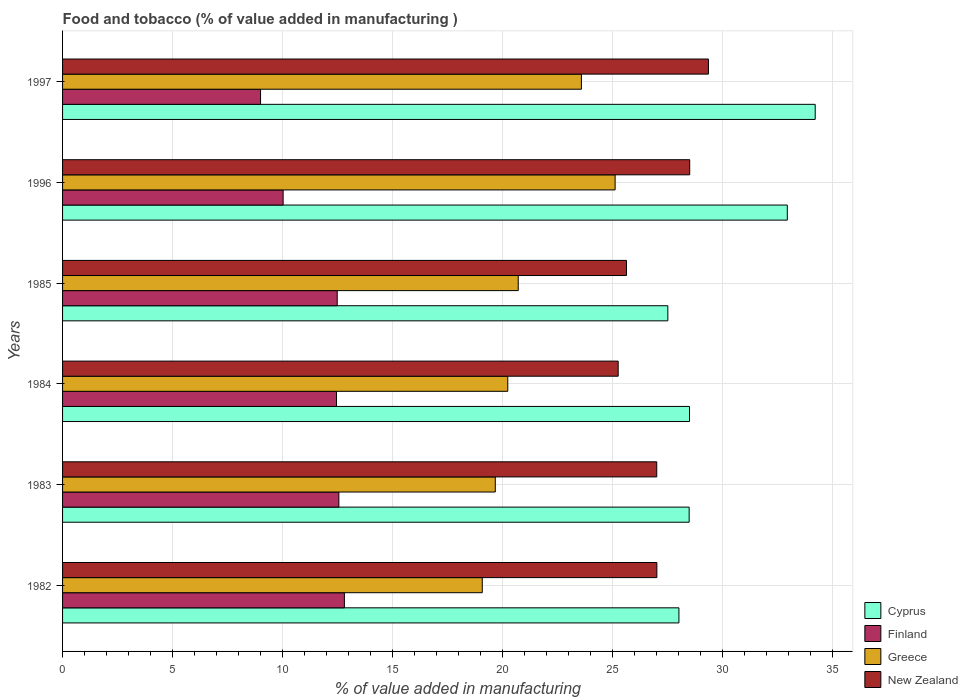Are the number of bars on each tick of the Y-axis equal?
Offer a terse response. Yes. How many bars are there on the 5th tick from the top?
Offer a terse response. 4. What is the value added in manufacturing food and tobacco in New Zealand in 1997?
Your answer should be compact. 29.37. Across all years, what is the maximum value added in manufacturing food and tobacco in Cyprus?
Your answer should be very brief. 34.23. Across all years, what is the minimum value added in manufacturing food and tobacco in Finland?
Offer a very short reply. 9. In which year was the value added in manufacturing food and tobacco in Finland maximum?
Ensure brevity in your answer.  1982. In which year was the value added in manufacturing food and tobacco in New Zealand minimum?
Your answer should be very brief. 1984. What is the total value added in manufacturing food and tobacco in Finland in the graph?
Provide a short and direct response. 69.36. What is the difference between the value added in manufacturing food and tobacco in Cyprus in 1982 and that in 1983?
Your answer should be very brief. -0.47. What is the difference between the value added in manufacturing food and tobacco in Greece in 1997 and the value added in manufacturing food and tobacco in New Zealand in 1984?
Keep it short and to the point. -1.67. What is the average value added in manufacturing food and tobacco in New Zealand per year?
Your response must be concise. 27.14. In the year 1985, what is the difference between the value added in manufacturing food and tobacco in Greece and value added in manufacturing food and tobacco in Finland?
Ensure brevity in your answer.  8.23. In how many years, is the value added in manufacturing food and tobacco in Greece greater than 7 %?
Make the answer very short. 6. What is the ratio of the value added in manufacturing food and tobacco in New Zealand in 1982 to that in 1996?
Provide a short and direct response. 0.95. Is the difference between the value added in manufacturing food and tobacco in Greece in 1984 and 1985 greater than the difference between the value added in manufacturing food and tobacco in Finland in 1984 and 1985?
Keep it short and to the point. No. What is the difference between the highest and the second highest value added in manufacturing food and tobacco in Greece?
Provide a succinct answer. 1.53. What is the difference between the highest and the lowest value added in manufacturing food and tobacco in Greece?
Offer a very short reply. 6.04. Is the sum of the value added in manufacturing food and tobacco in Cyprus in 1983 and 1985 greater than the maximum value added in manufacturing food and tobacco in Finland across all years?
Provide a short and direct response. Yes. What does the 2nd bar from the top in 1997 represents?
Provide a succinct answer. Greece. What does the 3rd bar from the bottom in 1997 represents?
Keep it short and to the point. Greece. How many bars are there?
Your response must be concise. 24. Are all the bars in the graph horizontal?
Ensure brevity in your answer.  Yes. How many years are there in the graph?
Offer a terse response. 6. What is the difference between two consecutive major ticks on the X-axis?
Ensure brevity in your answer.  5. Are the values on the major ticks of X-axis written in scientific E-notation?
Keep it short and to the point. No. Does the graph contain grids?
Your response must be concise. Yes. Where does the legend appear in the graph?
Give a very brief answer. Bottom right. How many legend labels are there?
Offer a very short reply. 4. How are the legend labels stacked?
Make the answer very short. Vertical. What is the title of the graph?
Offer a terse response. Food and tobacco (% of value added in manufacturing ). What is the label or title of the X-axis?
Offer a very short reply. % of value added in manufacturing. What is the label or title of the Y-axis?
Offer a very short reply. Years. What is the % of value added in manufacturing in Cyprus in 1982?
Offer a terse response. 28.03. What is the % of value added in manufacturing of Finland in 1982?
Ensure brevity in your answer.  12.82. What is the % of value added in manufacturing of Greece in 1982?
Keep it short and to the point. 19.09. What is the % of value added in manufacturing of New Zealand in 1982?
Your answer should be very brief. 27.03. What is the % of value added in manufacturing in Cyprus in 1983?
Provide a short and direct response. 28.49. What is the % of value added in manufacturing of Finland in 1983?
Ensure brevity in your answer.  12.56. What is the % of value added in manufacturing in Greece in 1983?
Ensure brevity in your answer.  19.68. What is the % of value added in manufacturing in New Zealand in 1983?
Keep it short and to the point. 27.02. What is the % of value added in manufacturing in Cyprus in 1984?
Offer a very short reply. 28.51. What is the % of value added in manufacturing of Finland in 1984?
Provide a succinct answer. 12.46. What is the % of value added in manufacturing in Greece in 1984?
Your response must be concise. 20.25. What is the % of value added in manufacturing of New Zealand in 1984?
Your answer should be very brief. 25.27. What is the % of value added in manufacturing of Cyprus in 1985?
Give a very brief answer. 27.52. What is the % of value added in manufacturing of Finland in 1985?
Make the answer very short. 12.49. What is the % of value added in manufacturing of Greece in 1985?
Provide a short and direct response. 20.72. What is the % of value added in manufacturing of New Zealand in 1985?
Provide a succinct answer. 25.64. What is the % of value added in manufacturing in Cyprus in 1996?
Keep it short and to the point. 32.96. What is the % of value added in manufacturing of Finland in 1996?
Keep it short and to the point. 10.03. What is the % of value added in manufacturing of Greece in 1996?
Your answer should be compact. 25.13. What is the % of value added in manufacturing in New Zealand in 1996?
Your answer should be compact. 28.52. What is the % of value added in manufacturing in Cyprus in 1997?
Offer a terse response. 34.23. What is the % of value added in manufacturing of Finland in 1997?
Offer a very short reply. 9. What is the % of value added in manufacturing of Greece in 1997?
Keep it short and to the point. 23.59. What is the % of value added in manufacturing of New Zealand in 1997?
Offer a terse response. 29.37. Across all years, what is the maximum % of value added in manufacturing in Cyprus?
Provide a short and direct response. 34.23. Across all years, what is the maximum % of value added in manufacturing in Finland?
Ensure brevity in your answer.  12.82. Across all years, what is the maximum % of value added in manufacturing in Greece?
Provide a short and direct response. 25.13. Across all years, what is the maximum % of value added in manufacturing in New Zealand?
Your response must be concise. 29.37. Across all years, what is the minimum % of value added in manufacturing in Cyprus?
Offer a terse response. 27.52. Across all years, what is the minimum % of value added in manufacturing in Finland?
Offer a terse response. 9. Across all years, what is the minimum % of value added in manufacturing in Greece?
Provide a short and direct response. 19.09. Across all years, what is the minimum % of value added in manufacturing in New Zealand?
Offer a very short reply. 25.27. What is the total % of value added in manufacturing in Cyprus in the graph?
Offer a very short reply. 179.74. What is the total % of value added in manufacturing of Finland in the graph?
Provide a short and direct response. 69.36. What is the total % of value added in manufacturing in Greece in the graph?
Give a very brief answer. 128.45. What is the total % of value added in manufacturing in New Zealand in the graph?
Your answer should be compact. 162.85. What is the difference between the % of value added in manufacturing of Cyprus in 1982 and that in 1983?
Your answer should be compact. -0.47. What is the difference between the % of value added in manufacturing in Finland in 1982 and that in 1983?
Make the answer very short. 0.25. What is the difference between the % of value added in manufacturing in Greece in 1982 and that in 1983?
Your answer should be compact. -0.59. What is the difference between the % of value added in manufacturing in New Zealand in 1982 and that in 1983?
Offer a terse response. 0.01. What is the difference between the % of value added in manufacturing in Cyprus in 1982 and that in 1984?
Provide a short and direct response. -0.48. What is the difference between the % of value added in manufacturing of Finland in 1982 and that in 1984?
Ensure brevity in your answer.  0.36. What is the difference between the % of value added in manufacturing in Greece in 1982 and that in 1984?
Your answer should be very brief. -1.16. What is the difference between the % of value added in manufacturing of New Zealand in 1982 and that in 1984?
Make the answer very short. 1.76. What is the difference between the % of value added in manufacturing in Cyprus in 1982 and that in 1985?
Provide a succinct answer. 0.5. What is the difference between the % of value added in manufacturing of Finland in 1982 and that in 1985?
Keep it short and to the point. 0.33. What is the difference between the % of value added in manufacturing in Greece in 1982 and that in 1985?
Give a very brief answer. -1.64. What is the difference between the % of value added in manufacturing of New Zealand in 1982 and that in 1985?
Provide a succinct answer. 1.38. What is the difference between the % of value added in manufacturing of Cyprus in 1982 and that in 1996?
Ensure brevity in your answer.  -4.93. What is the difference between the % of value added in manufacturing in Finland in 1982 and that in 1996?
Provide a succinct answer. 2.79. What is the difference between the % of value added in manufacturing in Greece in 1982 and that in 1996?
Your answer should be compact. -6.04. What is the difference between the % of value added in manufacturing of New Zealand in 1982 and that in 1996?
Your answer should be compact. -1.49. What is the difference between the % of value added in manufacturing in Cyprus in 1982 and that in 1997?
Offer a very short reply. -6.2. What is the difference between the % of value added in manufacturing of Finland in 1982 and that in 1997?
Make the answer very short. 3.81. What is the difference between the % of value added in manufacturing in Greece in 1982 and that in 1997?
Keep it short and to the point. -4.51. What is the difference between the % of value added in manufacturing in New Zealand in 1982 and that in 1997?
Offer a terse response. -2.34. What is the difference between the % of value added in manufacturing in Cyprus in 1983 and that in 1984?
Keep it short and to the point. -0.02. What is the difference between the % of value added in manufacturing of Finland in 1983 and that in 1984?
Offer a terse response. 0.11. What is the difference between the % of value added in manufacturing in Greece in 1983 and that in 1984?
Your answer should be compact. -0.57. What is the difference between the % of value added in manufacturing of New Zealand in 1983 and that in 1984?
Give a very brief answer. 1.75. What is the difference between the % of value added in manufacturing of Cyprus in 1983 and that in 1985?
Give a very brief answer. 0.97. What is the difference between the % of value added in manufacturing of Finland in 1983 and that in 1985?
Make the answer very short. 0.07. What is the difference between the % of value added in manufacturing in Greece in 1983 and that in 1985?
Your answer should be compact. -1.04. What is the difference between the % of value added in manufacturing in New Zealand in 1983 and that in 1985?
Your answer should be very brief. 1.38. What is the difference between the % of value added in manufacturing in Cyprus in 1983 and that in 1996?
Your response must be concise. -4.46. What is the difference between the % of value added in manufacturing in Finland in 1983 and that in 1996?
Your answer should be very brief. 2.53. What is the difference between the % of value added in manufacturing in Greece in 1983 and that in 1996?
Ensure brevity in your answer.  -5.45. What is the difference between the % of value added in manufacturing in New Zealand in 1983 and that in 1996?
Make the answer very short. -1.5. What is the difference between the % of value added in manufacturing of Cyprus in 1983 and that in 1997?
Provide a succinct answer. -5.73. What is the difference between the % of value added in manufacturing in Finland in 1983 and that in 1997?
Your response must be concise. 3.56. What is the difference between the % of value added in manufacturing in Greece in 1983 and that in 1997?
Make the answer very short. -3.92. What is the difference between the % of value added in manufacturing of New Zealand in 1983 and that in 1997?
Ensure brevity in your answer.  -2.35. What is the difference between the % of value added in manufacturing of Cyprus in 1984 and that in 1985?
Give a very brief answer. 0.99. What is the difference between the % of value added in manufacturing of Finland in 1984 and that in 1985?
Your response must be concise. -0.03. What is the difference between the % of value added in manufacturing in Greece in 1984 and that in 1985?
Ensure brevity in your answer.  -0.48. What is the difference between the % of value added in manufacturing of New Zealand in 1984 and that in 1985?
Give a very brief answer. -0.38. What is the difference between the % of value added in manufacturing of Cyprus in 1984 and that in 1996?
Give a very brief answer. -4.45. What is the difference between the % of value added in manufacturing in Finland in 1984 and that in 1996?
Make the answer very short. 2.43. What is the difference between the % of value added in manufacturing of Greece in 1984 and that in 1996?
Provide a succinct answer. -4.88. What is the difference between the % of value added in manufacturing of New Zealand in 1984 and that in 1996?
Make the answer very short. -3.25. What is the difference between the % of value added in manufacturing of Cyprus in 1984 and that in 1997?
Give a very brief answer. -5.72. What is the difference between the % of value added in manufacturing in Finland in 1984 and that in 1997?
Your answer should be very brief. 3.45. What is the difference between the % of value added in manufacturing of Greece in 1984 and that in 1997?
Your answer should be very brief. -3.35. What is the difference between the % of value added in manufacturing of New Zealand in 1984 and that in 1997?
Your answer should be very brief. -4.1. What is the difference between the % of value added in manufacturing of Cyprus in 1985 and that in 1996?
Keep it short and to the point. -5.43. What is the difference between the % of value added in manufacturing of Finland in 1985 and that in 1996?
Provide a short and direct response. 2.46. What is the difference between the % of value added in manufacturing in Greece in 1985 and that in 1996?
Give a very brief answer. -4.41. What is the difference between the % of value added in manufacturing in New Zealand in 1985 and that in 1996?
Your answer should be compact. -2.88. What is the difference between the % of value added in manufacturing in Cyprus in 1985 and that in 1997?
Your answer should be compact. -6.7. What is the difference between the % of value added in manufacturing of Finland in 1985 and that in 1997?
Give a very brief answer. 3.49. What is the difference between the % of value added in manufacturing of Greece in 1985 and that in 1997?
Ensure brevity in your answer.  -2.87. What is the difference between the % of value added in manufacturing of New Zealand in 1985 and that in 1997?
Ensure brevity in your answer.  -3.73. What is the difference between the % of value added in manufacturing of Cyprus in 1996 and that in 1997?
Offer a very short reply. -1.27. What is the difference between the % of value added in manufacturing of Finland in 1996 and that in 1997?
Ensure brevity in your answer.  1.03. What is the difference between the % of value added in manufacturing in Greece in 1996 and that in 1997?
Keep it short and to the point. 1.53. What is the difference between the % of value added in manufacturing in New Zealand in 1996 and that in 1997?
Ensure brevity in your answer.  -0.85. What is the difference between the % of value added in manufacturing of Cyprus in 1982 and the % of value added in manufacturing of Finland in 1983?
Your response must be concise. 15.46. What is the difference between the % of value added in manufacturing in Cyprus in 1982 and the % of value added in manufacturing in Greece in 1983?
Give a very brief answer. 8.35. What is the difference between the % of value added in manufacturing in Finland in 1982 and the % of value added in manufacturing in Greece in 1983?
Keep it short and to the point. -6.86. What is the difference between the % of value added in manufacturing of Finland in 1982 and the % of value added in manufacturing of New Zealand in 1983?
Provide a short and direct response. -14.2. What is the difference between the % of value added in manufacturing of Greece in 1982 and the % of value added in manufacturing of New Zealand in 1983?
Provide a succinct answer. -7.94. What is the difference between the % of value added in manufacturing in Cyprus in 1982 and the % of value added in manufacturing in Finland in 1984?
Make the answer very short. 15.57. What is the difference between the % of value added in manufacturing of Cyprus in 1982 and the % of value added in manufacturing of Greece in 1984?
Provide a short and direct response. 7.78. What is the difference between the % of value added in manufacturing of Cyprus in 1982 and the % of value added in manufacturing of New Zealand in 1984?
Offer a very short reply. 2.76. What is the difference between the % of value added in manufacturing of Finland in 1982 and the % of value added in manufacturing of Greece in 1984?
Provide a short and direct response. -7.43. What is the difference between the % of value added in manufacturing of Finland in 1982 and the % of value added in manufacturing of New Zealand in 1984?
Offer a terse response. -12.45. What is the difference between the % of value added in manufacturing of Greece in 1982 and the % of value added in manufacturing of New Zealand in 1984?
Offer a very short reply. -6.18. What is the difference between the % of value added in manufacturing of Cyprus in 1982 and the % of value added in manufacturing of Finland in 1985?
Your response must be concise. 15.54. What is the difference between the % of value added in manufacturing of Cyprus in 1982 and the % of value added in manufacturing of Greece in 1985?
Ensure brevity in your answer.  7.31. What is the difference between the % of value added in manufacturing in Cyprus in 1982 and the % of value added in manufacturing in New Zealand in 1985?
Give a very brief answer. 2.38. What is the difference between the % of value added in manufacturing in Finland in 1982 and the % of value added in manufacturing in Greece in 1985?
Your response must be concise. -7.91. What is the difference between the % of value added in manufacturing of Finland in 1982 and the % of value added in manufacturing of New Zealand in 1985?
Your response must be concise. -12.83. What is the difference between the % of value added in manufacturing in Greece in 1982 and the % of value added in manufacturing in New Zealand in 1985?
Provide a short and direct response. -6.56. What is the difference between the % of value added in manufacturing of Cyprus in 1982 and the % of value added in manufacturing of Finland in 1996?
Keep it short and to the point. 18. What is the difference between the % of value added in manufacturing in Cyprus in 1982 and the % of value added in manufacturing in Greece in 1996?
Offer a very short reply. 2.9. What is the difference between the % of value added in manufacturing of Cyprus in 1982 and the % of value added in manufacturing of New Zealand in 1996?
Your response must be concise. -0.49. What is the difference between the % of value added in manufacturing of Finland in 1982 and the % of value added in manufacturing of Greece in 1996?
Your answer should be compact. -12.31. What is the difference between the % of value added in manufacturing of Finland in 1982 and the % of value added in manufacturing of New Zealand in 1996?
Your response must be concise. -15.7. What is the difference between the % of value added in manufacturing of Greece in 1982 and the % of value added in manufacturing of New Zealand in 1996?
Your answer should be very brief. -9.43. What is the difference between the % of value added in manufacturing of Cyprus in 1982 and the % of value added in manufacturing of Finland in 1997?
Your answer should be compact. 19.03. What is the difference between the % of value added in manufacturing in Cyprus in 1982 and the % of value added in manufacturing in Greece in 1997?
Your answer should be very brief. 4.43. What is the difference between the % of value added in manufacturing in Cyprus in 1982 and the % of value added in manufacturing in New Zealand in 1997?
Make the answer very short. -1.34. What is the difference between the % of value added in manufacturing of Finland in 1982 and the % of value added in manufacturing of Greece in 1997?
Offer a terse response. -10.78. What is the difference between the % of value added in manufacturing of Finland in 1982 and the % of value added in manufacturing of New Zealand in 1997?
Ensure brevity in your answer.  -16.55. What is the difference between the % of value added in manufacturing in Greece in 1982 and the % of value added in manufacturing in New Zealand in 1997?
Make the answer very short. -10.29. What is the difference between the % of value added in manufacturing in Cyprus in 1983 and the % of value added in manufacturing in Finland in 1984?
Keep it short and to the point. 16.04. What is the difference between the % of value added in manufacturing in Cyprus in 1983 and the % of value added in manufacturing in Greece in 1984?
Provide a short and direct response. 8.25. What is the difference between the % of value added in manufacturing in Cyprus in 1983 and the % of value added in manufacturing in New Zealand in 1984?
Provide a succinct answer. 3.23. What is the difference between the % of value added in manufacturing of Finland in 1983 and the % of value added in manufacturing of Greece in 1984?
Give a very brief answer. -7.68. What is the difference between the % of value added in manufacturing in Finland in 1983 and the % of value added in manufacturing in New Zealand in 1984?
Your response must be concise. -12.7. What is the difference between the % of value added in manufacturing of Greece in 1983 and the % of value added in manufacturing of New Zealand in 1984?
Provide a succinct answer. -5.59. What is the difference between the % of value added in manufacturing in Cyprus in 1983 and the % of value added in manufacturing in Finland in 1985?
Offer a very short reply. 16. What is the difference between the % of value added in manufacturing of Cyprus in 1983 and the % of value added in manufacturing of Greece in 1985?
Provide a succinct answer. 7.77. What is the difference between the % of value added in manufacturing in Cyprus in 1983 and the % of value added in manufacturing in New Zealand in 1985?
Offer a very short reply. 2.85. What is the difference between the % of value added in manufacturing in Finland in 1983 and the % of value added in manufacturing in Greece in 1985?
Make the answer very short. -8.16. What is the difference between the % of value added in manufacturing of Finland in 1983 and the % of value added in manufacturing of New Zealand in 1985?
Ensure brevity in your answer.  -13.08. What is the difference between the % of value added in manufacturing in Greece in 1983 and the % of value added in manufacturing in New Zealand in 1985?
Your answer should be very brief. -5.97. What is the difference between the % of value added in manufacturing in Cyprus in 1983 and the % of value added in manufacturing in Finland in 1996?
Give a very brief answer. 18.46. What is the difference between the % of value added in manufacturing in Cyprus in 1983 and the % of value added in manufacturing in Greece in 1996?
Your response must be concise. 3.37. What is the difference between the % of value added in manufacturing of Cyprus in 1983 and the % of value added in manufacturing of New Zealand in 1996?
Provide a succinct answer. -0.02. What is the difference between the % of value added in manufacturing in Finland in 1983 and the % of value added in manufacturing in Greece in 1996?
Offer a terse response. -12.56. What is the difference between the % of value added in manufacturing in Finland in 1983 and the % of value added in manufacturing in New Zealand in 1996?
Provide a succinct answer. -15.95. What is the difference between the % of value added in manufacturing in Greece in 1983 and the % of value added in manufacturing in New Zealand in 1996?
Your answer should be very brief. -8.84. What is the difference between the % of value added in manufacturing in Cyprus in 1983 and the % of value added in manufacturing in Finland in 1997?
Your answer should be compact. 19.49. What is the difference between the % of value added in manufacturing of Cyprus in 1983 and the % of value added in manufacturing of Greece in 1997?
Offer a very short reply. 4.9. What is the difference between the % of value added in manufacturing of Cyprus in 1983 and the % of value added in manufacturing of New Zealand in 1997?
Your answer should be compact. -0.88. What is the difference between the % of value added in manufacturing in Finland in 1983 and the % of value added in manufacturing in Greece in 1997?
Ensure brevity in your answer.  -11.03. What is the difference between the % of value added in manufacturing of Finland in 1983 and the % of value added in manufacturing of New Zealand in 1997?
Your answer should be very brief. -16.81. What is the difference between the % of value added in manufacturing of Greece in 1983 and the % of value added in manufacturing of New Zealand in 1997?
Your answer should be compact. -9.69. What is the difference between the % of value added in manufacturing in Cyprus in 1984 and the % of value added in manufacturing in Finland in 1985?
Keep it short and to the point. 16.02. What is the difference between the % of value added in manufacturing in Cyprus in 1984 and the % of value added in manufacturing in Greece in 1985?
Offer a very short reply. 7.79. What is the difference between the % of value added in manufacturing in Cyprus in 1984 and the % of value added in manufacturing in New Zealand in 1985?
Your response must be concise. 2.87. What is the difference between the % of value added in manufacturing in Finland in 1984 and the % of value added in manufacturing in Greece in 1985?
Your answer should be compact. -8.26. What is the difference between the % of value added in manufacturing in Finland in 1984 and the % of value added in manufacturing in New Zealand in 1985?
Offer a terse response. -13.19. What is the difference between the % of value added in manufacturing of Greece in 1984 and the % of value added in manufacturing of New Zealand in 1985?
Your answer should be very brief. -5.4. What is the difference between the % of value added in manufacturing of Cyprus in 1984 and the % of value added in manufacturing of Finland in 1996?
Give a very brief answer. 18.48. What is the difference between the % of value added in manufacturing of Cyprus in 1984 and the % of value added in manufacturing of Greece in 1996?
Ensure brevity in your answer.  3.38. What is the difference between the % of value added in manufacturing in Cyprus in 1984 and the % of value added in manufacturing in New Zealand in 1996?
Provide a short and direct response. -0.01. What is the difference between the % of value added in manufacturing in Finland in 1984 and the % of value added in manufacturing in Greece in 1996?
Offer a very short reply. -12.67. What is the difference between the % of value added in manufacturing in Finland in 1984 and the % of value added in manufacturing in New Zealand in 1996?
Make the answer very short. -16.06. What is the difference between the % of value added in manufacturing of Greece in 1984 and the % of value added in manufacturing of New Zealand in 1996?
Provide a short and direct response. -8.27. What is the difference between the % of value added in manufacturing of Cyprus in 1984 and the % of value added in manufacturing of Finland in 1997?
Make the answer very short. 19.51. What is the difference between the % of value added in manufacturing in Cyprus in 1984 and the % of value added in manufacturing in Greece in 1997?
Keep it short and to the point. 4.92. What is the difference between the % of value added in manufacturing in Cyprus in 1984 and the % of value added in manufacturing in New Zealand in 1997?
Keep it short and to the point. -0.86. What is the difference between the % of value added in manufacturing in Finland in 1984 and the % of value added in manufacturing in Greece in 1997?
Offer a very short reply. -11.14. What is the difference between the % of value added in manufacturing in Finland in 1984 and the % of value added in manufacturing in New Zealand in 1997?
Give a very brief answer. -16.91. What is the difference between the % of value added in manufacturing of Greece in 1984 and the % of value added in manufacturing of New Zealand in 1997?
Offer a terse response. -9.13. What is the difference between the % of value added in manufacturing of Cyprus in 1985 and the % of value added in manufacturing of Finland in 1996?
Your answer should be compact. 17.5. What is the difference between the % of value added in manufacturing in Cyprus in 1985 and the % of value added in manufacturing in Greece in 1996?
Provide a succinct answer. 2.4. What is the difference between the % of value added in manufacturing in Cyprus in 1985 and the % of value added in manufacturing in New Zealand in 1996?
Offer a terse response. -0.99. What is the difference between the % of value added in manufacturing in Finland in 1985 and the % of value added in manufacturing in Greece in 1996?
Offer a terse response. -12.64. What is the difference between the % of value added in manufacturing of Finland in 1985 and the % of value added in manufacturing of New Zealand in 1996?
Provide a succinct answer. -16.03. What is the difference between the % of value added in manufacturing of Greece in 1985 and the % of value added in manufacturing of New Zealand in 1996?
Give a very brief answer. -7.8. What is the difference between the % of value added in manufacturing of Cyprus in 1985 and the % of value added in manufacturing of Finland in 1997?
Your response must be concise. 18.52. What is the difference between the % of value added in manufacturing of Cyprus in 1985 and the % of value added in manufacturing of Greece in 1997?
Provide a succinct answer. 3.93. What is the difference between the % of value added in manufacturing of Cyprus in 1985 and the % of value added in manufacturing of New Zealand in 1997?
Provide a succinct answer. -1.85. What is the difference between the % of value added in manufacturing in Finland in 1985 and the % of value added in manufacturing in Greece in 1997?
Offer a very short reply. -11.11. What is the difference between the % of value added in manufacturing in Finland in 1985 and the % of value added in manufacturing in New Zealand in 1997?
Make the answer very short. -16.88. What is the difference between the % of value added in manufacturing of Greece in 1985 and the % of value added in manufacturing of New Zealand in 1997?
Provide a short and direct response. -8.65. What is the difference between the % of value added in manufacturing in Cyprus in 1996 and the % of value added in manufacturing in Finland in 1997?
Your answer should be compact. 23.95. What is the difference between the % of value added in manufacturing in Cyprus in 1996 and the % of value added in manufacturing in Greece in 1997?
Give a very brief answer. 9.36. What is the difference between the % of value added in manufacturing of Cyprus in 1996 and the % of value added in manufacturing of New Zealand in 1997?
Give a very brief answer. 3.59. What is the difference between the % of value added in manufacturing of Finland in 1996 and the % of value added in manufacturing of Greece in 1997?
Provide a succinct answer. -13.57. What is the difference between the % of value added in manufacturing in Finland in 1996 and the % of value added in manufacturing in New Zealand in 1997?
Keep it short and to the point. -19.34. What is the difference between the % of value added in manufacturing of Greece in 1996 and the % of value added in manufacturing of New Zealand in 1997?
Your response must be concise. -4.24. What is the average % of value added in manufacturing in Cyprus per year?
Give a very brief answer. 29.96. What is the average % of value added in manufacturing of Finland per year?
Provide a short and direct response. 11.56. What is the average % of value added in manufacturing of Greece per year?
Your answer should be very brief. 21.41. What is the average % of value added in manufacturing in New Zealand per year?
Your answer should be compact. 27.14. In the year 1982, what is the difference between the % of value added in manufacturing of Cyprus and % of value added in manufacturing of Finland?
Offer a terse response. 15.21. In the year 1982, what is the difference between the % of value added in manufacturing of Cyprus and % of value added in manufacturing of Greece?
Keep it short and to the point. 8.94. In the year 1982, what is the difference between the % of value added in manufacturing in Cyprus and % of value added in manufacturing in New Zealand?
Make the answer very short. 1. In the year 1982, what is the difference between the % of value added in manufacturing of Finland and % of value added in manufacturing of Greece?
Your answer should be very brief. -6.27. In the year 1982, what is the difference between the % of value added in manufacturing of Finland and % of value added in manufacturing of New Zealand?
Your response must be concise. -14.21. In the year 1982, what is the difference between the % of value added in manufacturing in Greece and % of value added in manufacturing in New Zealand?
Provide a succinct answer. -7.94. In the year 1983, what is the difference between the % of value added in manufacturing of Cyprus and % of value added in manufacturing of Finland?
Your response must be concise. 15.93. In the year 1983, what is the difference between the % of value added in manufacturing of Cyprus and % of value added in manufacturing of Greece?
Keep it short and to the point. 8.82. In the year 1983, what is the difference between the % of value added in manufacturing in Cyprus and % of value added in manufacturing in New Zealand?
Offer a terse response. 1.47. In the year 1983, what is the difference between the % of value added in manufacturing of Finland and % of value added in manufacturing of Greece?
Your answer should be compact. -7.11. In the year 1983, what is the difference between the % of value added in manufacturing in Finland and % of value added in manufacturing in New Zealand?
Provide a succinct answer. -14.46. In the year 1983, what is the difference between the % of value added in manufacturing in Greece and % of value added in manufacturing in New Zealand?
Keep it short and to the point. -7.34. In the year 1984, what is the difference between the % of value added in manufacturing of Cyprus and % of value added in manufacturing of Finland?
Ensure brevity in your answer.  16.05. In the year 1984, what is the difference between the % of value added in manufacturing of Cyprus and % of value added in manufacturing of Greece?
Offer a very short reply. 8.26. In the year 1984, what is the difference between the % of value added in manufacturing of Cyprus and % of value added in manufacturing of New Zealand?
Your response must be concise. 3.24. In the year 1984, what is the difference between the % of value added in manufacturing in Finland and % of value added in manufacturing in Greece?
Your answer should be very brief. -7.79. In the year 1984, what is the difference between the % of value added in manufacturing of Finland and % of value added in manufacturing of New Zealand?
Make the answer very short. -12.81. In the year 1984, what is the difference between the % of value added in manufacturing of Greece and % of value added in manufacturing of New Zealand?
Offer a very short reply. -5.02. In the year 1985, what is the difference between the % of value added in manufacturing in Cyprus and % of value added in manufacturing in Finland?
Keep it short and to the point. 15.04. In the year 1985, what is the difference between the % of value added in manufacturing of Cyprus and % of value added in manufacturing of Greece?
Make the answer very short. 6.8. In the year 1985, what is the difference between the % of value added in manufacturing in Cyprus and % of value added in manufacturing in New Zealand?
Your answer should be very brief. 1.88. In the year 1985, what is the difference between the % of value added in manufacturing in Finland and % of value added in manufacturing in Greece?
Keep it short and to the point. -8.23. In the year 1985, what is the difference between the % of value added in manufacturing in Finland and % of value added in manufacturing in New Zealand?
Keep it short and to the point. -13.15. In the year 1985, what is the difference between the % of value added in manufacturing in Greece and % of value added in manufacturing in New Zealand?
Provide a succinct answer. -4.92. In the year 1996, what is the difference between the % of value added in manufacturing of Cyprus and % of value added in manufacturing of Finland?
Provide a short and direct response. 22.93. In the year 1996, what is the difference between the % of value added in manufacturing of Cyprus and % of value added in manufacturing of Greece?
Your answer should be very brief. 7.83. In the year 1996, what is the difference between the % of value added in manufacturing of Cyprus and % of value added in manufacturing of New Zealand?
Your response must be concise. 4.44. In the year 1996, what is the difference between the % of value added in manufacturing in Finland and % of value added in manufacturing in Greece?
Your response must be concise. -15.1. In the year 1996, what is the difference between the % of value added in manufacturing in Finland and % of value added in manufacturing in New Zealand?
Ensure brevity in your answer.  -18.49. In the year 1996, what is the difference between the % of value added in manufacturing of Greece and % of value added in manufacturing of New Zealand?
Your answer should be very brief. -3.39. In the year 1997, what is the difference between the % of value added in manufacturing in Cyprus and % of value added in manufacturing in Finland?
Your response must be concise. 25.22. In the year 1997, what is the difference between the % of value added in manufacturing in Cyprus and % of value added in manufacturing in Greece?
Provide a short and direct response. 10.63. In the year 1997, what is the difference between the % of value added in manufacturing of Cyprus and % of value added in manufacturing of New Zealand?
Make the answer very short. 4.86. In the year 1997, what is the difference between the % of value added in manufacturing in Finland and % of value added in manufacturing in Greece?
Your response must be concise. -14.59. In the year 1997, what is the difference between the % of value added in manufacturing of Finland and % of value added in manufacturing of New Zealand?
Offer a very short reply. -20.37. In the year 1997, what is the difference between the % of value added in manufacturing in Greece and % of value added in manufacturing in New Zealand?
Your response must be concise. -5.78. What is the ratio of the % of value added in manufacturing in Cyprus in 1982 to that in 1983?
Your response must be concise. 0.98. What is the ratio of the % of value added in manufacturing of Greece in 1982 to that in 1983?
Keep it short and to the point. 0.97. What is the ratio of the % of value added in manufacturing of New Zealand in 1982 to that in 1983?
Your response must be concise. 1. What is the ratio of the % of value added in manufacturing in Cyprus in 1982 to that in 1984?
Your answer should be very brief. 0.98. What is the ratio of the % of value added in manufacturing of Finland in 1982 to that in 1984?
Keep it short and to the point. 1.03. What is the ratio of the % of value added in manufacturing of Greece in 1982 to that in 1984?
Your response must be concise. 0.94. What is the ratio of the % of value added in manufacturing of New Zealand in 1982 to that in 1984?
Ensure brevity in your answer.  1.07. What is the ratio of the % of value added in manufacturing in Cyprus in 1982 to that in 1985?
Keep it short and to the point. 1.02. What is the ratio of the % of value added in manufacturing of Finland in 1982 to that in 1985?
Give a very brief answer. 1.03. What is the ratio of the % of value added in manufacturing of Greece in 1982 to that in 1985?
Provide a succinct answer. 0.92. What is the ratio of the % of value added in manufacturing of New Zealand in 1982 to that in 1985?
Offer a very short reply. 1.05. What is the ratio of the % of value added in manufacturing of Cyprus in 1982 to that in 1996?
Your answer should be very brief. 0.85. What is the ratio of the % of value added in manufacturing in Finland in 1982 to that in 1996?
Your response must be concise. 1.28. What is the ratio of the % of value added in manufacturing in Greece in 1982 to that in 1996?
Offer a terse response. 0.76. What is the ratio of the % of value added in manufacturing of New Zealand in 1982 to that in 1996?
Your answer should be compact. 0.95. What is the ratio of the % of value added in manufacturing of Cyprus in 1982 to that in 1997?
Provide a succinct answer. 0.82. What is the ratio of the % of value added in manufacturing in Finland in 1982 to that in 1997?
Provide a succinct answer. 1.42. What is the ratio of the % of value added in manufacturing of Greece in 1982 to that in 1997?
Your answer should be compact. 0.81. What is the ratio of the % of value added in manufacturing in New Zealand in 1982 to that in 1997?
Ensure brevity in your answer.  0.92. What is the ratio of the % of value added in manufacturing of Finland in 1983 to that in 1984?
Make the answer very short. 1.01. What is the ratio of the % of value added in manufacturing in New Zealand in 1983 to that in 1984?
Provide a succinct answer. 1.07. What is the ratio of the % of value added in manufacturing in Cyprus in 1983 to that in 1985?
Provide a short and direct response. 1.04. What is the ratio of the % of value added in manufacturing in Greece in 1983 to that in 1985?
Provide a short and direct response. 0.95. What is the ratio of the % of value added in manufacturing in New Zealand in 1983 to that in 1985?
Provide a short and direct response. 1.05. What is the ratio of the % of value added in manufacturing of Cyprus in 1983 to that in 1996?
Your answer should be compact. 0.86. What is the ratio of the % of value added in manufacturing in Finland in 1983 to that in 1996?
Offer a very short reply. 1.25. What is the ratio of the % of value added in manufacturing in Greece in 1983 to that in 1996?
Your answer should be compact. 0.78. What is the ratio of the % of value added in manufacturing of New Zealand in 1983 to that in 1996?
Make the answer very short. 0.95. What is the ratio of the % of value added in manufacturing in Cyprus in 1983 to that in 1997?
Your answer should be very brief. 0.83. What is the ratio of the % of value added in manufacturing of Finland in 1983 to that in 1997?
Your answer should be very brief. 1.4. What is the ratio of the % of value added in manufacturing of Greece in 1983 to that in 1997?
Your answer should be compact. 0.83. What is the ratio of the % of value added in manufacturing in Cyprus in 1984 to that in 1985?
Your response must be concise. 1.04. What is the ratio of the % of value added in manufacturing of New Zealand in 1984 to that in 1985?
Give a very brief answer. 0.99. What is the ratio of the % of value added in manufacturing of Cyprus in 1984 to that in 1996?
Keep it short and to the point. 0.87. What is the ratio of the % of value added in manufacturing in Finland in 1984 to that in 1996?
Make the answer very short. 1.24. What is the ratio of the % of value added in manufacturing in Greece in 1984 to that in 1996?
Ensure brevity in your answer.  0.81. What is the ratio of the % of value added in manufacturing of New Zealand in 1984 to that in 1996?
Your answer should be compact. 0.89. What is the ratio of the % of value added in manufacturing of Cyprus in 1984 to that in 1997?
Give a very brief answer. 0.83. What is the ratio of the % of value added in manufacturing of Finland in 1984 to that in 1997?
Ensure brevity in your answer.  1.38. What is the ratio of the % of value added in manufacturing in Greece in 1984 to that in 1997?
Offer a very short reply. 0.86. What is the ratio of the % of value added in manufacturing of New Zealand in 1984 to that in 1997?
Provide a short and direct response. 0.86. What is the ratio of the % of value added in manufacturing in Cyprus in 1985 to that in 1996?
Offer a terse response. 0.84. What is the ratio of the % of value added in manufacturing in Finland in 1985 to that in 1996?
Make the answer very short. 1.25. What is the ratio of the % of value added in manufacturing in Greece in 1985 to that in 1996?
Your response must be concise. 0.82. What is the ratio of the % of value added in manufacturing in New Zealand in 1985 to that in 1996?
Give a very brief answer. 0.9. What is the ratio of the % of value added in manufacturing of Cyprus in 1985 to that in 1997?
Provide a short and direct response. 0.8. What is the ratio of the % of value added in manufacturing in Finland in 1985 to that in 1997?
Your answer should be very brief. 1.39. What is the ratio of the % of value added in manufacturing in Greece in 1985 to that in 1997?
Your response must be concise. 0.88. What is the ratio of the % of value added in manufacturing in New Zealand in 1985 to that in 1997?
Your answer should be compact. 0.87. What is the ratio of the % of value added in manufacturing in Cyprus in 1996 to that in 1997?
Ensure brevity in your answer.  0.96. What is the ratio of the % of value added in manufacturing of Finland in 1996 to that in 1997?
Your answer should be compact. 1.11. What is the ratio of the % of value added in manufacturing of Greece in 1996 to that in 1997?
Provide a short and direct response. 1.06. What is the ratio of the % of value added in manufacturing in New Zealand in 1996 to that in 1997?
Make the answer very short. 0.97. What is the difference between the highest and the second highest % of value added in manufacturing of Cyprus?
Keep it short and to the point. 1.27. What is the difference between the highest and the second highest % of value added in manufacturing in Finland?
Keep it short and to the point. 0.25. What is the difference between the highest and the second highest % of value added in manufacturing in Greece?
Your answer should be compact. 1.53. What is the difference between the highest and the second highest % of value added in manufacturing in New Zealand?
Your answer should be compact. 0.85. What is the difference between the highest and the lowest % of value added in manufacturing in Cyprus?
Ensure brevity in your answer.  6.7. What is the difference between the highest and the lowest % of value added in manufacturing of Finland?
Your answer should be very brief. 3.81. What is the difference between the highest and the lowest % of value added in manufacturing in Greece?
Offer a terse response. 6.04. What is the difference between the highest and the lowest % of value added in manufacturing of New Zealand?
Ensure brevity in your answer.  4.1. 